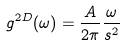Convert formula to latex. <formula><loc_0><loc_0><loc_500><loc_500>g ^ { 2 D } ( \omega ) = \frac { A } { 2 \pi } \frac { \omega } { s ^ { 2 } }</formula> 